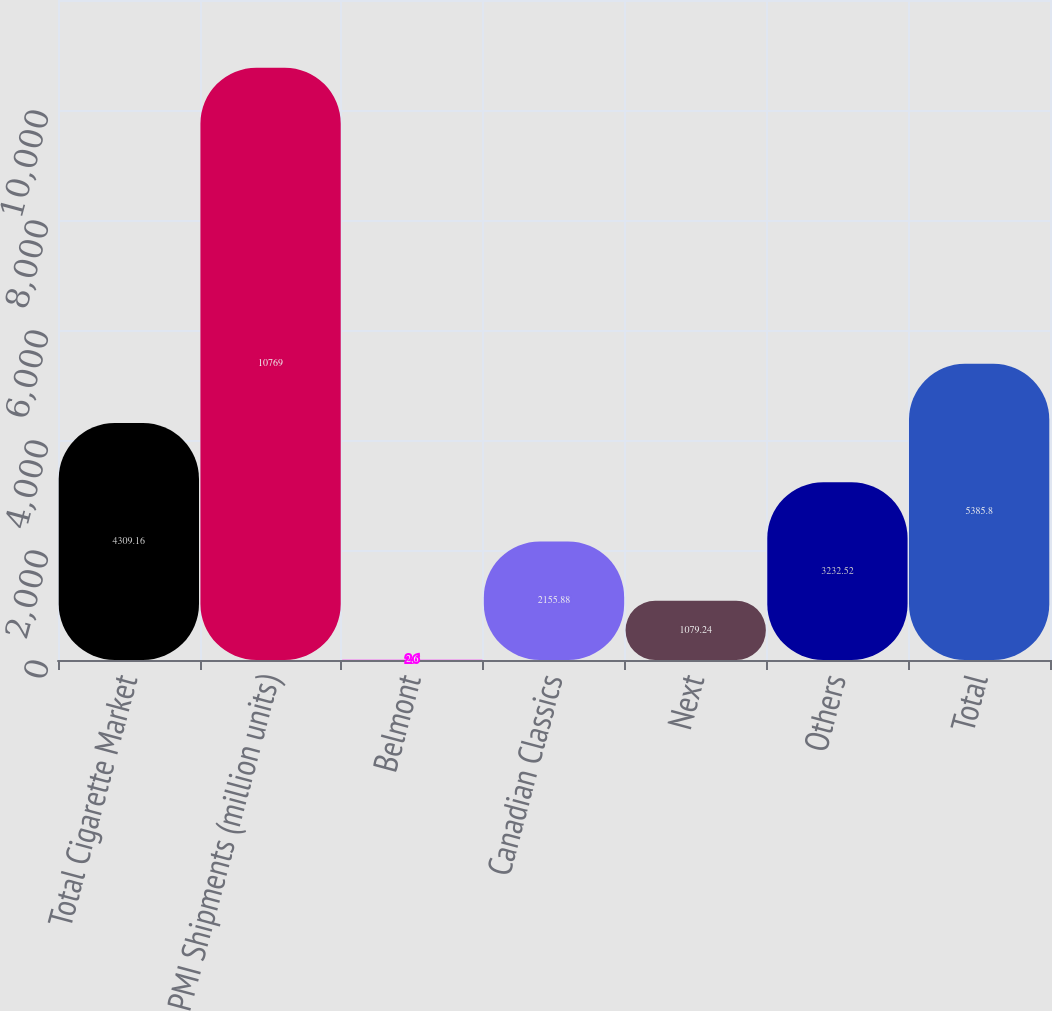Convert chart. <chart><loc_0><loc_0><loc_500><loc_500><bar_chart><fcel>Total Cigarette Market<fcel>PMI Shipments (million units)<fcel>Belmont<fcel>Canadian Classics<fcel>Next<fcel>Others<fcel>Total<nl><fcel>4309.16<fcel>10769<fcel>2.6<fcel>2155.88<fcel>1079.24<fcel>3232.52<fcel>5385.8<nl></chart> 